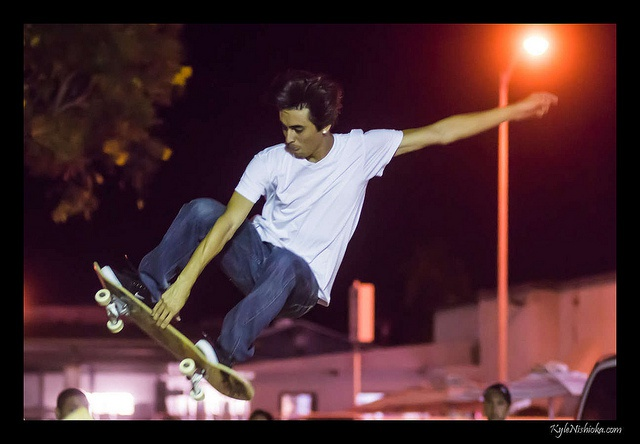Describe the objects in this image and their specific colors. I can see people in black, lavender, navy, and purple tones, skateboard in black, gray, maroon, and tan tones, people in black, khaki, brown, and maroon tones, people in black, maroon, and brown tones, and people in black, maroon, and brown tones in this image. 